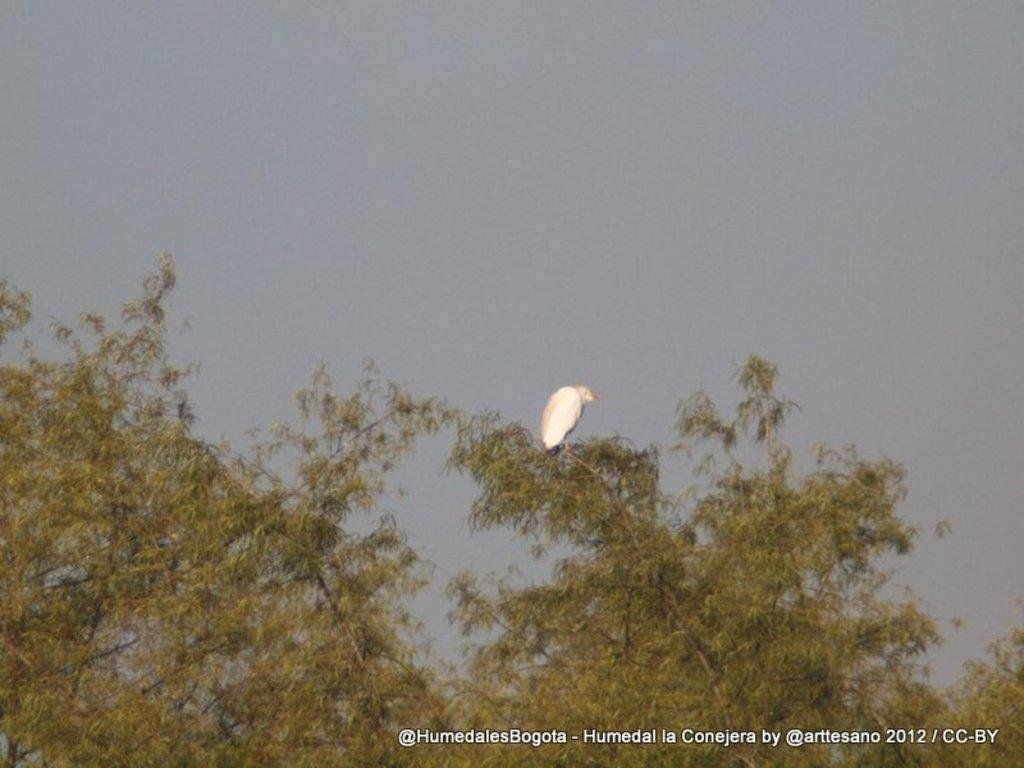What is the main subject in the middle of the image? There is a bird in the middle of the image. What type of vegetation is present at the bottom of the image? There are trees at the bottom of the image. What is visible at the top of the image? The sky is visible at the top of the image. What advice does the bird give to the kite in the image? There is no kite present in the image, so the bird cannot give any advice to it. 